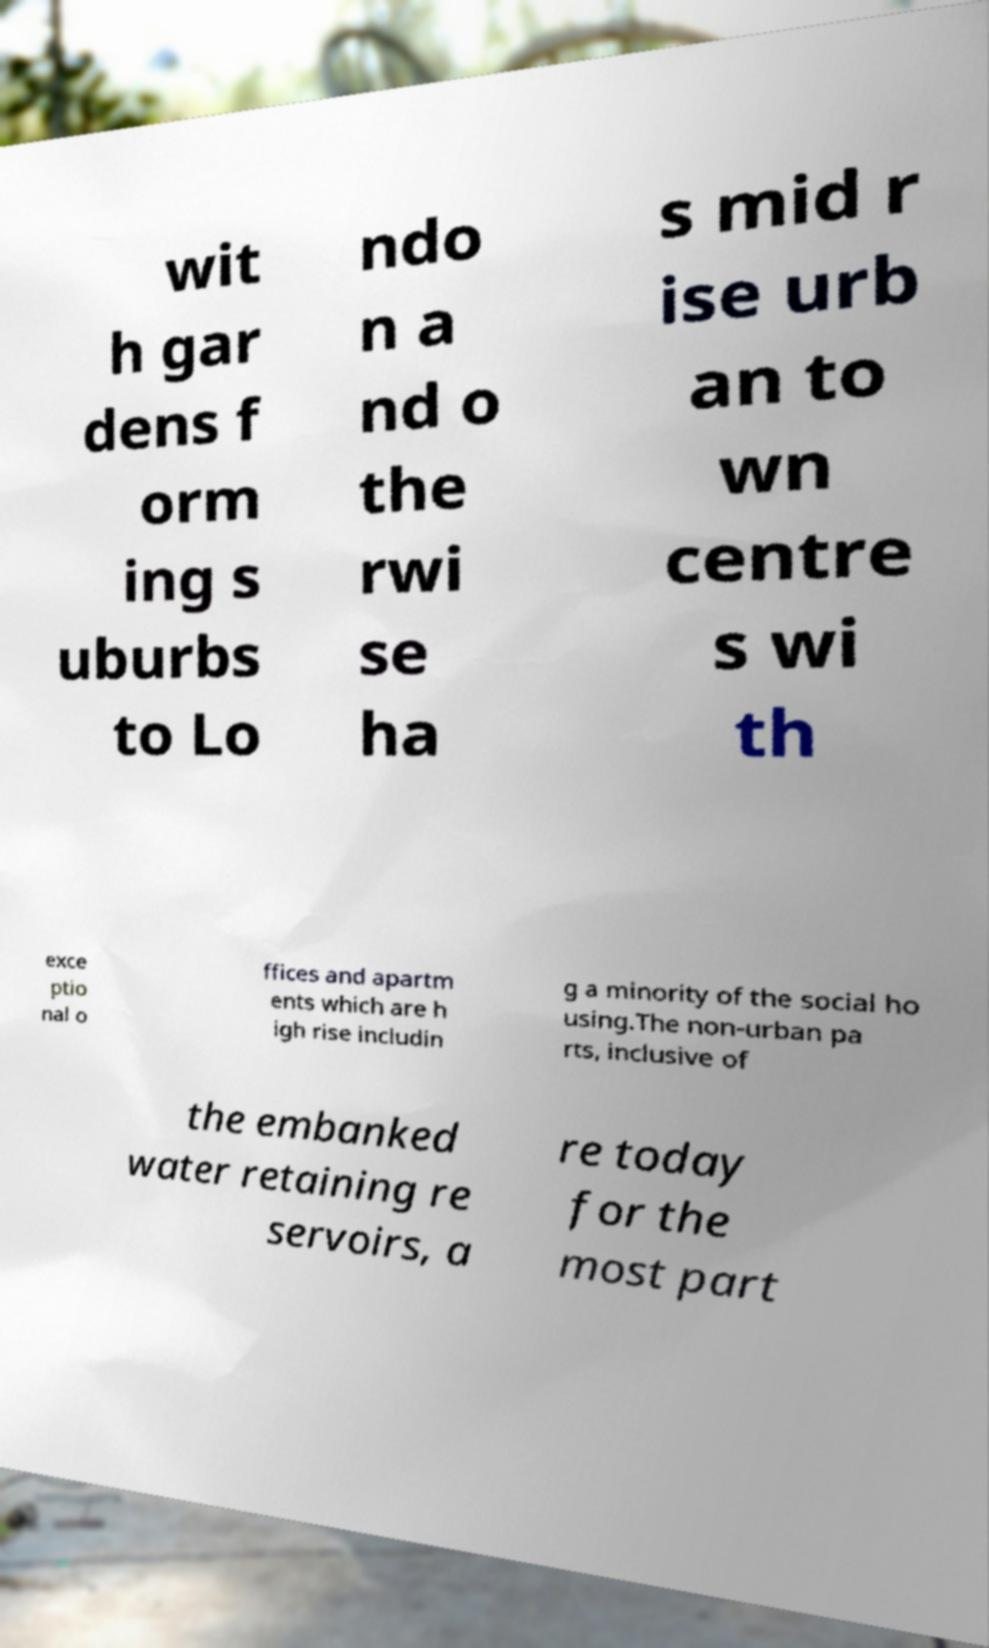Please read and relay the text visible in this image. What does it say? wit h gar dens f orm ing s uburbs to Lo ndo n a nd o the rwi se ha s mid r ise urb an to wn centre s wi th exce ptio nal o ffices and apartm ents which are h igh rise includin g a minority of the social ho using.The non-urban pa rts, inclusive of the embanked water retaining re servoirs, a re today for the most part 